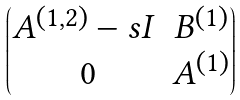Convert formula to latex. <formula><loc_0><loc_0><loc_500><loc_500>\begin{pmatrix} A ^ { ( 1 , 2 ) } - s I & B ^ { ( 1 ) } \\ \ 0 & A ^ { ( 1 ) } \end{pmatrix}</formula> 